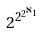Convert formula to latex. <formula><loc_0><loc_0><loc_500><loc_500>2 ^ { 2 ^ { 2 ^ { \aleph _ { 1 } } } }</formula> 